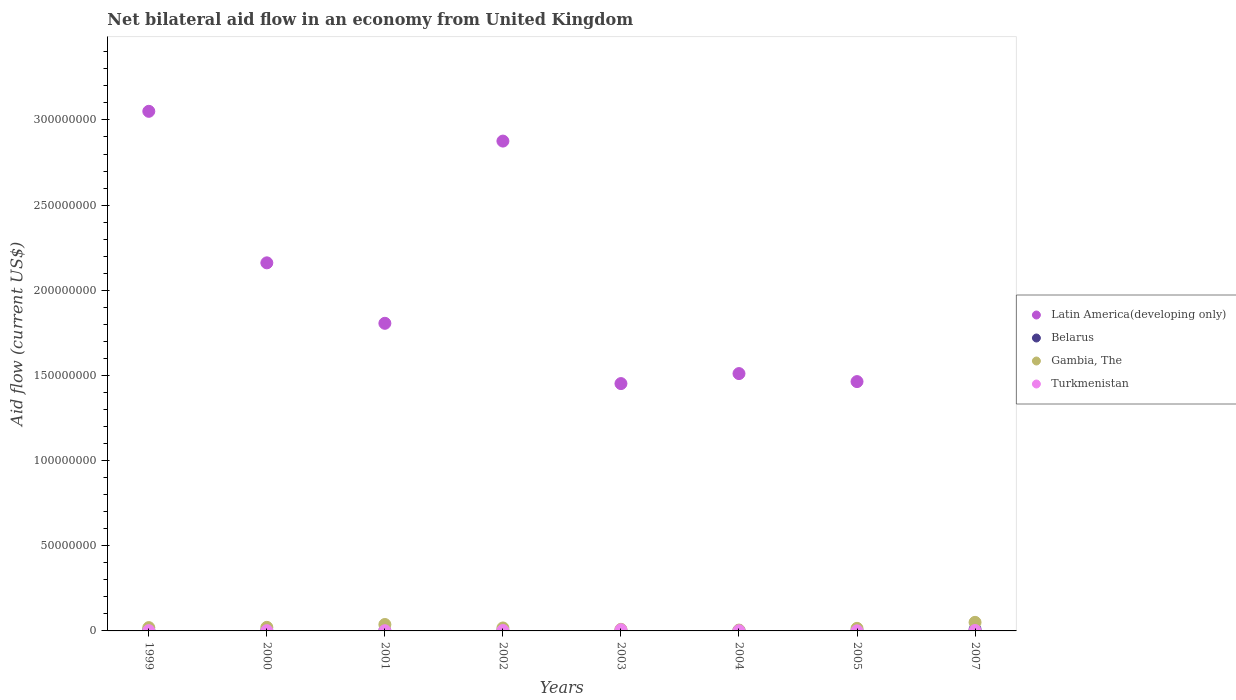What is the net bilateral aid flow in Latin America(developing only) in 2005?
Provide a short and direct response. 1.46e+08. Across all years, what is the maximum net bilateral aid flow in Gambia, The?
Keep it short and to the point. 5.03e+06. Across all years, what is the minimum net bilateral aid flow in Latin America(developing only)?
Keep it short and to the point. 0. What is the total net bilateral aid flow in Gambia, The in the graph?
Your answer should be compact. 1.75e+07. What is the difference between the net bilateral aid flow in Gambia, The in 2001 and that in 2005?
Provide a short and direct response. 2.26e+06. What is the difference between the net bilateral aid flow in Gambia, The in 2002 and the net bilateral aid flow in Latin America(developing only) in 2005?
Provide a succinct answer. -1.45e+08. What is the average net bilateral aid flow in Belarus per year?
Provide a succinct answer. 2.76e+05. In the year 2000, what is the difference between the net bilateral aid flow in Gambia, The and net bilateral aid flow in Turkmenistan?
Your response must be concise. 1.96e+06. In how many years, is the net bilateral aid flow in Gambia, The greater than 200000000 US$?
Make the answer very short. 0. Is the difference between the net bilateral aid flow in Gambia, The in 2001 and 2005 greater than the difference between the net bilateral aid flow in Turkmenistan in 2001 and 2005?
Your answer should be very brief. Yes. What is the difference between the highest and the second highest net bilateral aid flow in Latin America(developing only)?
Your answer should be compact. 1.75e+07. What is the difference between the highest and the lowest net bilateral aid flow in Turkmenistan?
Provide a succinct answer. 6.20e+05. In how many years, is the net bilateral aid flow in Turkmenistan greater than the average net bilateral aid flow in Turkmenistan taken over all years?
Offer a terse response. 3. Is the sum of the net bilateral aid flow in Belarus in 1999 and 2001 greater than the maximum net bilateral aid flow in Latin America(developing only) across all years?
Give a very brief answer. No. Is it the case that in every year, the sum of the net bilateral aid flow in Gambia, The and net bilateral aid flow in Turkmenistan  is greater than the net bilateral aid flow in Latin America(developing only)?
Your response must be concise. No. Is the net bilateral aid flow in Turkmenistan strictly greater than the net bilateral aid flow in Latin America(developing only) over the years?
Provide a short and direct response. No. How many dotlines are there?
Make the answer very short. 4. What is the difference between two consecutive major ticks on the Y-axis?
Ensure brevity in your answer.  5.00e+07. Does the graph contain any zero values?
Offer a very short reply. Yes. Does the graph contain grids?
Provide a short and direct response. No. Where does the legend appear in the graph?
Your answer should be very brief. Center right. How many legend labels are there?
Keep it short and to the point. 4. How are the legend labels stacked?
Your response must be concise. Vertical. What is the title of the graph?
Give a very brief answer. Net bilateral aid flow in an economy from United Kingdom. Does "Bhutan" appear as one of the legend labels in the graph?
Ensure brevity in your answer.  No. What is the label or title of the X-axis?
Keep it short and to the point. Years. What is the Aid flow (current US$) in Latin America(developing only) in 1999?
Make the answer very short. 3.05e+08. What is the Aid flow (current US$) in Belarus in 1999?
Make the answer very short. 5.80e+05. What is the Aid flow (current US$) of Gambia, The in 1999?
Offer a terse response. 1.94e+06. What is the Aid flow (current US$) of Latin America(developing only) in 2000?
Make the answer very short. 2.16e+08. What is the Aid flow (current US$) of Gambia, The in 2000?
Offer a terse response. 2.10e+06. What is the Aid flow (current US$) of Latin America(developing only) in 2001?
Give a very brief answer. 1.81e+08. What is the Aid flow (current US$) in Belarus in 2001?
Ensure brevity in your answer.  1.30e+05. What is the Aid flow (current US$) of Gambia, The in 2001?
Make the answer very short. 3.77e+06. What is the Aid flow (current US$) in Latin America(developing only) in 2002?
Offer a very short reply. 2.88e+08. What is the Aid flow (current US$) in Gambia, The in 2002?
Offer a very short reply. 1.73e+06. What is the Aid flow (current US$) of Turkmenistan in 2002?
Give a very brief answer. 2.40e+05. What is the Aid flow (current US$) in Latin America(developing only) in 2003?
Make the answer very short. 1.45e+08. What is the Aid flow (current US$) of Gambia, The in 2003?
Give a very brief answer. 9.30e+05. What is the Aid flow (current US$) in Turkmenistan in 2003?
Offer a very short reply. 6.70e+05. What is the Aid flow (current US$) in Latin America(developing only) in 2004?
Offer a very short reply. 1.51e+08. What is the Aid flow (current US$) of Belarus in 2004?
Provide a short and direct response. 2.00e+05. What is the Aid flow (current US$) of Turkmenistan in 2004?
Your answer should be compact. 1.10e+05. What is the Aid flow (current US$) of Latin America(developing only) in 2005?
Offer a very short reply. 1.46e+08. What is the Aid flow (current US$) in Belarus in 2005?
Provide a succinct answer. 1.10e+05. What is the Aid flow (current US$) of Gambia, The in 2005?
Ensure brevity in your answer.  1.51e+06. What is the Aid flow (current US$) of Latin America(developing only) in 2007?
Offer a terse response. 0. What is the Aid flow (current US$) in Belarus in 2007?
Your response must be concise. 8.20e+05. What is the Aid flow (current US$) of Gambia, The in 2007?
Your answer should be very brief. 5.03e+06. What is the Aid flow (current US$) in Turkmenistan in 2007?
Keep it short and to the point. 2.40e+05. Across all years, what is the maximum Aid flow (current US$) of Latin America(developing only)?
Your response must be concise. 3.05e+08. Across all years, what is the maximum Aid flow (current US$) in Belarus?
Provide a succinct answer. 8.20e+05. Across all years, what is the maximum Aid flow (current US$) of Gambia, The?
Keep it short and to the point. 5.03e+06. Across all years, what is the maximum Aid flow (current US$) in Turkmenistan?
Give a very brief answer. 6.70e+05. What is the total Aid flow (current US$) in Latin America(developing only) in the graph?
Keep it short and to the point. 1.43e+09. What is the total Aid flow (current US$) of Belarus in the graph?
Offer a terse response. 2.21e+06. What is the total Aid flow (current US$) of Gambia, The in the graph?
Ensure brevity in your answer.  1.75e+07. What is the total Aid flow (current US$) of Turkmenistan in the graph?
Make the answer very short. 1.73e+06. What is the difference between the Aid flow (current US$) of Latin America(developing only) in 1999 and that in 2000?
Keep it short and to the point. 8.90e+07. What is the difference between the Aid flow (current US$) of Belarus in 1999 and that in 2000?
Your answer should be compact. 3.70e+05. What is the difference between the Aid flow (current US$) in Gambia, The in 1999 and that in 2000?
Keep it short and to the point. -1.60e+05. What is the difference between the Aid flow (current US$) of Turkmenistan in 1999 and that in 2000?
Provide a short and direct response. 2.00e+04. What is the difference between the Aid flow (current US$) of Latin America(developing only) in 1999 and that in 2001?
Your answer should be very brief. 1.24e+08. What is the difference between the Aid flow (current US$) of Gambia, The in 1999 and that in 2001?
Your answer should be very brief. -1.83e+06. What is the difference between the Aid flow (current US$) of Latin America(developing only) in 1999 and that in 2002?
Your answer should be very brief. 1.75e+07. What is the difference between the Aid flow (current US$) of Belarus in 1999 and that in 2002?
Your answer should be compact. 4.90e+05. What is the difference between the Aid flow (current US$) of Gambia, The in 1999 and that in 2002?
Ensure brevity in your answer.  2.10e+05. What is the difference between the Aid flow (current US$) in Turkmenistan in 1999 and that in 2002?
Keep it short and to the point. -8.00e+04. What is the difference between the Aid flow (current US$) of Latin America(developing only) in 1999 and that in 2003?
Ensure brevity in your answer.  1.60e+08. What is the difference between the Aid flow (current US$) in Belarus in 1999 and that in 2003?
Ensure brevity in your answer.  5.10e+05. What is the difference between the Aid flow (current US$) of Gambia, The in 1999 and that in 2003?
Make the answer very short. 1.01e+06. What is the difference between the Aid flow (current US$) in Turkmenistan in 1999 and that in 2003?
Ensure brevity in your answer.  -5.10e+05. What is the difference between the Aid flow (current US$) in Latin America(developing only) in 1999 and that in 2004?
Your answer should be very brief. 1.54e+08. What is the difference between the Aid flow (current US$) of Belarus in 1999 and that in 2004?
Ensure brevity in your answer.  3.80e+05. What is the difference between the Aid flow (current US$) in Gambia, The in 1999 and that in 2004?
Give a very brief answer. 1.45e+06. What is the difference between the Aid flow (current US$) in Turkmenistan in 1999 and that in 2004?
Offer a very short reply. 5.00e+04. What is the difference between the Aid flow (current US$) of Latin America(developing only) in 1999 and that in 2005?
Your response must be concise. 1.59e+08. What is the difference between the Aid flow (current US$) of Belarus in 1999 and that in 2005?
Provide a short and direct response. 4.70e+05. What is the difference between the Aid flow (current US$) of Turkmenistan in 1999 and that in 2005?
Your answer should be compact. 1.10e+05. What is the difference between the Aid flow (current US$) of Belarus in 1999 and that in 2007?
Your response must be concise. -2.40e+05. What is the difference between the Aid flow (current US$) in Gambia, The in 1999 and that in 2007?
Keep it short and to the point. -3.09e+06. What is the difference between the Aid flow (current US$) of Latin America(developing only) in 2000 and that in 2001?
Make the answer very short. 3.55e+07. What is the difference between the Aid flow (current US$) of Gambia, The in 2000 and that in 2001?
Provide a succinct answer. -1.67e+06. What is the difference between the Aid flow (current US$) in Turkmenistan in 2000 and that in 2001?
Provide a succinct answer. 2.00e+04. What is the difference between the Aid flow (current US$) of Latin America(developing only) in 2000 and that in 2002?
Offer a very short reply. -7.15e+07. What is the difference between the Aid flow (current US$) in Belarus in 2000 and that in 2002?
Provide a succinct answer. 1.20e+05. What is the difference between the Aid flow (current US$) in Gambia, The in 2000 and that in 2002?
Your response must be concise. 3.70e+05. What is the difference between the Aid flow (current US$) in Latin America(developing only) in 2000 and that in 2003?
Ensure brevity in your answer.  7.09e+07. What is the difference between the Aid flow (current US$) of Gambia, The in 2000 and that in 2003?
Make the answer very short. 1.17e+06. What is the difference between the Aid flow (current US$) in Turkmenistan in 2000 and that in 2003?
Give a very brief answer. -5.30e+05. What is the difference between the Aid flow (current US$) of Latin America(developing only) in 2000 and that in 2004?
Provide a succinct answer. 6.50e+07. What is the difference between the Aid flow (current US$) of Gambia, The in 2000 and that in 2004?
Offer a very short reply. 1.61e+06. What is the difference between the Aid flow (current US$) of Turkmenistan in 2000 and that in 2004?
Provide a short and direct response. 3.00e+04. What is the difference between the Aid flow (current US$) in Latin America(developing only) in 2000 and that in 2005?
Give a very brief answer. 6.97e+07. What is the difference between the Aid flow (current US$) of Belarus in 2000 and that in 2005?
Give a very brief answer. 1.00e+05. What is the difference between the Aid flow (current US$) of Gambia, The in 2000 and that in 2005?
Keep it short and to the point. 5.90e+05. What is the difference between the Aid flow (current US$) of Turkmenistan in 2000 and that in 2005?
Offer a terse response. 9.00e+04. What is the difference between the Aid flow (current US$) in Belarus in 2000 and that in 2007?
Ensure brevity in your answer.  -6.10e+05. What is the difference between the Aid flow (current US$) in Gambia, The in 2000 and that in 2007?
Offer a very short reply. -2.93e+06. What is the difference between the Aid flow (current US$) in Turkmenistan in 2000 and that in 2007?
Your answer should be very brief. -1.00e+05. What is the difference between the Aid flow (current US$) of Latin America(developing only) in 2001 and that in 2002?
Offer a very short reply. -1.07e+08. What is the difference between the Aid flow (current US$) of Gambia, The in 2001 and that in 2002?
Keep it short and to the point. 2.04e+06. What is the difference between the Aid flow (current US$) in Latin America(developing only) in 2001 and that in 2003?
Provide a succinct answer. 3.54e+07. What is the difference between the Aid flow (current US$) in Belarus in 2001 and that in 2003?
Your response must be concise. 6.00e+04. What is the difference between the Aid flow (current US$) in Gambia, The in 2001 and that in 2003?
Provide a short and direct response. 2.84e+06. What is the difference between the Aid flow (current US$) of Turkmenistan in 2001 and that in 2003?
Provide a succinct answer. -5.50e+05. What is the difference between the Aid flow (current US$) of Latin America(developing only) in 2001 and that in 2004?
Offer a very short reply. 2.95e+07. What is the difference between the Aid flow (current US$) in Gambia, The in 2001 and that in 2004?
Make the answer very short. 3.28e+06. What is the difference between the Aid flow (current US$) in Turkmenistan in 2001 and that in 2004?
Offer a terse response. 10000. What is the difference between the Aid flow (current US$) in Latin America(developing only) in 2001 and that in 2005?
Your answer should be very brief. 3.42e+07. What is the difference between the Aid flow (current US$) of Gambia, The in 2001 and that in 2005?
Give a very brief answer. 2.26e+06. What is the difference between the Aid flow (current US$) in Turkmenistan in 2001 and that in 2005?
Your response must be concise. 7.00e+04. What is the difference between the Aid flow (current US$) in Belarus in 2001 and that in 2007?
Your answer should be very brief. -6.90e+05. What is the difference between the Aid flow (current US$) of Gambia, The in 2001 and that in 2007?
Your answer should be compact. -1.26e+06. What is the difference between the Aid flow (current US$) in Latin America(developing only) in 2002 and that in 2003?
Provide a short and direct response. 1.42e+08. What is the difference between the Aid flow (current US$) in Turkmenistan in 2002 and that in 2003?
Offer a very short reply. -4.30e+05. What is the difference between the Aid flow (current US$) in Latin America(developing only) in 2002 and that in 2004?
Your response must be concise. 1.36e+08. What is the difference between the Aid flow (current US$) of Gambia, The in 2002 and that in 2004?
Give a very brief answer. 1.24e+06. What is the difference between the Aid flow (current US$) in Latin America(developing only) in 2002 and that in 2005?
Provide a short and direct response. 1.41e+08. What is the difference between the Aid flow (current US$) of Belarus in 2002 and that in 2007?
Offer a very short reply. -7.30e+05. What is the difference between the Aid flow (current US$) of Gambia, The in 2002 and that in 2007?
Offer a terse response. -3.30e+06. What is the difference between the Aid flow (current US$) in Latin America(developing only) in 2003 and that in 2004?
Give a very brief answer. -5.87e+06. What is the difference between the Aid flow (current US$) of Turkmenistan in 2003 and that in 2004?
Provide a short and direct response. 5.60e+05. What is the difference between the Aid flow (current US$) of Latin America(developing only) in 2003 and that in 2005?
Your answer should be compact. -1.17e+06. What is the difference between the Aid flow (current US$) in Gambia, The in 2003 and that in 2005?
Keep it short and to the point. -5.80e+05. What is the difference between the Aid flow (current US$) of Turkmenistan in 2003 and that in 2005?
Offer a terse response. 6.20e+05. What is the difference between the Aid flow (current US$) of Belarus in 2003 and that in 2007?
Keep it short and to the point. -7.50e+05. What is the difference between the Aid flow (current US$) of Gambia, The in 2003 and that in 2007?
Make the answer very short. -4.10e+06. What is the difference between the Aid flow (current US$) in Latin America(developing only) in 2004 and that in 2005?
Offer a terse response. 4.70e+06. What is the difference between the Aid flow (current US$) in Gambia, The in 2004 and that in 2005?
Offer a very short reply. -1.02e+06. What is the difference between the Aid flow (current US$) of Turkmenistan in 2004 and that in 2005?
Keep it short and to the point. 6.00e+04. What is the difference between the Aid flow (current US$) in Belarus in 2004 and that in 2007?
Keep it short and to the point. -6.20e+05. What is the difference between the Aid flow (current US$) of Gambia, The in 2004 and that in 2007?
Make the answer very short. -4.54e+06. What is the difference between the Aid flow (current US$) of Turkmenistan in 2004 and that in 2007?
Ensure brevity in your answer.  -1.30e+05. What is the difference between the Aid flow (current US$) of Belarus in 2005 and that in 2007?
Provide a short and direct response. -7.10e+05. What is the difference between the Aid flow (current US$) of Gambia, The in 2005 and that in 2007?
Ensure brevity in your answer.  -3.52e+06. What is the difference between the Aid flow (current US$) of Turkmenistan in 2005 and that in 2007?
Provide a short and direct response. -1.90e+05. What is the difference between the Aid flow (current US$) of Latin America(developing only) in 1999 and the Aid flow (current US$) of Belarus in 2000?
Your answer should be compact. 3.05e+08. What is the difference between the Aid flow (current US$) in Latin America(developing only) in 1999 and the Aid flow (current US$) in Gambia, The in 2000?
Your answer should be compact. 3.03e+08. What is the difference between the Aid flow (current US$) in Latin America(developing only) in 1999 and the Aid flow (current US$) in Turkmenistan in 2000?
Offer a very short reply. 3.05e+08. What is the difference between the Aid flow (current US$) in Belarus in 1999 and the Aid flow (current US$) in Gambia, The in 2000?
Your answer should be very brief. -1.52e+06. What is the difference between the Aid flow (current US$) of Gambia, The in 1999 and the Aid flow (current US$) of Turkmenistan in 2000?
Your answer should be very brief. 1.80e+06. What is the difference between the Aid flow (current US$) in Latin America(developing only) in 1999 and the Aid flow (current US$) in Belarus in 2001?
Provide a succinct answer. 3.05e+08. What is the difference between the Aid flow (current US$) in Latin America(developing only) in 1999 and the Aid flow (current US$) in Gambia, The in 2001?
Provide a succinct answer. 3.01e+08. What is the difference between the Aid flow (current US$) in Latin America(developing only) in 1999 and the Aid flow (current US$) in Turkmenistan in 2001?
Provide a short and direct response. 3.05e+08. What is the difference between the Aid flow (current US$) of Belarus in 1999 and the Aid flow (current US$) of Gambia, The in 2001?
Provide a succinct answer. -3.19e+06. What is the difference between the Aid flow (current US$) of Gambia, The in 1999 and the Aid flow (current US$) of Turkmenistan in 2001?
Your answer should be compact. 1.82e+06. What is the difference between the Aid flow (current US$) in Latin America(developing only) in 1999 and the Aid flow (current US$) in Belarus in 2002?
Offer a terse response. 3.05e+08. What is the difference between the Aid flow (current US$) of Latin America(developing only) in 1999 and the Aid flow (current US$) of Gambia, The in 2002?
Keep it short and to the point. 3.03e+08. What is the difference between the Aid flow (current US$) in Latin America(developing only) in 1999 and the Aid flow (current US$) in Turkmenistan in 2002?
Offer a very short reply. 3.05e+08. What is the difference between the Aid flow (current US$) in Belarus in 1999 and the Aid flow (current US$) in Gambia, The in 2002?
Give a very brief answer. -1.15e+06. What is the difference between the Aid flow (current US$) in Belarus in 1999 and the Aid flow (current US$) in Turkmenistan in 2002?
Ensure brevity in your answer.  3.40e+05. What is the difference between the Aid flow (current US$) of Gambia, The in 1999 and the Aid flow (current US$) of Turkmenistan in 2002?
Provide a succinct answer. 1.70e+06. What is the difference between the Aid flow (current US$) in Latin America(developing only) in 1999 and the Aid flow (current US$) in Belarus in 2003?
Give a very brief answer. 3.05e+08. What is the difference between the Aid flow (current US$) in Latin America(developing only) in 1999 and the Aid flow (current US$) in Gambia, The in 2003?
Offer a terse response. 3.04e+08. What is the difference between the Aid flow (current US$) of Latin America(developing only) in 1999 and the Aid flow (current US$) of Turkmenistan in 2003?
Make the answer very short. 3.04e+08. What is the difference between the Aid flow (current US$) of Belarus in 1999 and the Aid flow (current US$) of Gambia, The in 2003?
Offer a very short reply. -3.50e+05. What is the difference between the Aid flow (current US$) in Gambia, The in 1999 and the Aid flow (current US$) in Turkmenistan in 2003?
Keep it short and to the point. 1.27e+06. What is the difference between the Aid flow (current US$) of Latin America(developing only) in 1999 and the Aid flow (current US$) of Belarus in 2004?
Provide a short and direct response. 3.05e+08. What is the difference between the Aid flow (current US$) of Latin America(developing only) in 1999 and the Aid flow (current US$) of Gambia, The in 2004?
Keep it short and to the point. 3.05e+08. What is the difference between the Aid flow (current US$) in Latin America(developing only) in 1999 and the Aid flow (current US$) in Turkmenistan in 2004?
Offer a terse response. 3.05e+08. What is the difference between the Aid flow (current US$) of Belarus in 1999 and the Aid flow (current US$) of Turkmenistan in 2004?
Offer a very short reply. 4.70e+05. What is the difference between the Aid flow (current US$) in Gambia, The in 1999 and the Aid flow (current US$) in Turkmenistan in 2004?
Offer a terse response. 1.83e+06. What is the difference between the Aid flow (current US$) in Latin America(developing only) in 1999 and the Aid flow (current US$) in Belarus in 2005?
Your answer should be very brief. 3.05e+08. What is the difference between the Aid flow (current US$) of Latin America(developing only) in 1999 and the Aid flow (current US$) of Gambia, The in 2005?
Provide a short and direct response. 3.04e+08. What is the difference between the Aid flow (current US$) in Latin America(developing only) in 1999 and the Aid flow (current US$) in Turkmenistan in 2005?
Your answer should be compact. 3.05e+08. What is the difference between the Aid flow (current US$) in Belarus in 1999 and the Aid flow (current US$) in Gambia, The in 2005?
Make the answer very short. -9.30e+05. What is the difference between the Aid flow (current US$) in Belarus in 1999 and the Aid flow (current US$) in Turkmenistan in 2005?
Offer a terse response. 5.30e+05. What is the difference between the Aid flow (current US$) in Gambia, The in 1999 and the Aid flow (current US$) in Turkmenistan in 2005?
Your answer should be very brief. 1.89e+06. What is the difference between the Aid flow (current US$) in Latin America(developing only) in 1999 and the Aid flow (current US$) in Belarus in 2007?
Ensure brevity in your answer.  3.04e+08. What is the difference between the Aid flow (current US$) in Latin America(developing only) in 1999 and the Aid flow (current US$) in Gambia, The in 2007?
Give a very brief answer. 3.00e+08. What is the difference between the Aid flow (current US$) in Latin America(developing only) in 1999 and the Aid flow (current US$) in Turkmenistan in 2007?
Give a very brief answer. 3.05e+08. What is the difference between the Aid flow (current US$) in Belarus in 1999 and the Aid flow (current US$) in Gambia, The in 2007?
Provide a short and direct response. -4.45e+06. What is the difference between the Aid flow (current US$) of Belarus in 1999 and the Aid flow (current US$) of Turkmenistan in 2007?
Keep it short and to the point. 3.40e+05. What is the difference between the Aid flow (current US$) of Gambia, The in 1999 and the Aid flow (current US$) of Turkmenistan in 2007?
Make the answer very short. 1.70e+06. What is the difference between the Aid flow (current US$) of Latin America(developing only) in 2000 and the Aid flow (current US$) of Belarus in 2001?
Keep it short and to the point. 2.16e+08. What is the difference between the Aid flow (current US$) of Latin America(developing only) in 2000 and the Aid flow (current US$) of Gambia, The in 2001?
Ensure brevity in your answer.  2.12e+08. What is the difference between the Aid flow (current US$) in Latin America(developing only) in 2000 and the Aid flow (current US$) in Turkmenistan in 2001?
Provide a succinct answer. 2.16e+08. What is the difference between the Aid flow (current US$) of Belarus in 2000 and the Aid flow (current US$) of Gambia, The in 2001?
Offer a very short reply. -3.56e+06. What is the difference between the Aid flow (current US$) in Belarus in 2000 and the Aid flow (current US$) in Turkmenistan in 2001?
Your answer should be compact. 9.00e+04. What is the difference between the Aid flow (current US$) in Gambia, The in 2000 and the Aid flow (current US$) in Turkmenistan in 2001?
Make the answer very short. 1.98e+06. What is the difference between the Aid flow (current US$) of Latin America(developing only) in 2000 and the Aid flow (current US$) of Belarus in 2002?
Offer a terse response. 2.16e+08. What is the difference between the Aid flow (current US$) of Latin America(developing only) in 2000 and the Aid flow (current US$) of Gambia, The in 2002?
Your response must be concise. 2.14e+08. What is the difference between the Aid flow (current US$) in Latin America(developing only) in 2000 and the Aid flow (current US$) in Turkmenistan in 2002?
Give a very brief answer. 2.16e+08. What is the difference between the Aid flow (current US$) of Belarus in 2000 and the Aid flow (current US$) of Gambia, The in 2002?
Provide a succinct answer. -1.52e+06. What is the difference between the Aid flow (current US$) in Belarus in 2000 and the Aid flow (current US$) in Turkmenistan in 2002?
Provide a short and direct response. -3.00e+04. What is the difference between the Aid flow (current US$) of Gambia, The in 2000 and the Aid flow (current US$) of Turkmenistan in 2002?
Your response must be concise. 1.86e+06. What is the difference between the Aid flow (current US$) in Latin America(developing only) in 2000 and the Aid flow (current US$) in Belarus in 2003?
Your response must be concise. 2.16e+08. What is the difference between the Aid flow (current US$) of Latin America(developing only) in 2000 and the Aid flow (current US$) of Gambia, The in 2003?
Keep it short and to the point. 2.15e+08. What is the difference between the Aid flow (current US$) in Latin America(developing only) in 2000 and the Aid flow (current US$) in Turkmenistan in 2003?
Your response must be concise. 2.15e+08. What is the difference between the Aid flow (current US$) in Belarus in 2000 and the Aid flow (current US$) in Gambia, The in 2003?
Your response must be concise. -7.20e+05. What is the difference between the Aid flow (current US$) in Belarus in 2000 and the Aid flow (current US$) in Turkmenistan in 2003?
Keep it short and to the point. -4.60e+05. What is the difference between the Aid flow (current US$) in Gambia, The in 2000 and the Aid flow (current US$) in Turkmenistan in 2003?
Your answer should be very brief. 1.43e+06. What is the difference between the Aid flow (current US$) in Latin America(developing only) in 2000 and the Aid flow (current US$) in Belarus in 2004?
Your response must be concise. 2.16e+08. What is the difference between the Aid flow (current US$) of Latin America(developing only) in 2000 and the Aid flow (current US$) of Gambia, The in 2004?
Your answer should be compact. 2.16e+08. What is the difference between the Aid flow (current US$) in Latin America(developing only) in 2000 and the Aid flow (current US$) in Turkmenistan in 2004?
Your answer should be very brief. 2.16e+08. What is the difference between the Aid flow (current US$) of Belarus in 2000 and the Aid flow (current US$) of Gambia, The in 2004?
Your response must be concise. -2.80e+05. What is the difference between the Aid flow (current US$) in Belarus in 2000 and the Aid flow (current US$) in Turkmenistan in 2004?
Provide a succinct answer. 1.00e+05. What is the difference between the Aid flow (current US$) of Gambia, The in 2000 and the Aid flow (current US$) of Turkmenistan in 2004?
Give a very brief answer. 1.99e+06. What is the difference between the Aid flow (current US$) in Latin America(developing only) in 2000 and the Aid flow (current US$) in Belarus in 2005?
Provide a short and direct response. 2.16e+08. What is the difference between the Aid flow (current US$) of Latin America(developing only) in 2000 and the Aid flow (current US$) of Gambia, The in 2005?
Provide a short and direct response. 2.15e+08. What is the difference between the Aid flow (current US$) of Latin America(developing only) in 2000 and the Aid flow (current US$) of Turkmenistan in 2005?
Offer a terse response. 2.16e+08. What is the difference between the Aid flow (current US$) in Belarus in 2000 and the Aid flow (current US$) in Gambia, The in 2005?
Ensure brevity in your answer.  -1.30e+06. What is the difference between the Aid flow (current US$) of Gambia, The in 2000 and the Aid flow (current US$) of Turkmenistan in 2005?
Offer a terse response. 2.05e+06. What is the difference between the Aid flow (current US$) of Latin America(developing only) in 2000 and the Aid flow (current US$) of Belarus in 2007?
Your answer should be compact. 2.15e+08. What is the difference between the Aid flow (current US$) in Latin America(developing only) in 2000 and the Aid flow (current US$) in Gambia, The in 2007?
Ensure brevity in your answer.  2.11e+08. What is the difference between the Aid flow (current US$) of Latin America(developing only) in 2000 and the Aid flow (current US$) of Turkmenistan in 2007?
Ensure brevity in your answer.  2.16e+08. What is the difference between the Aid flow (current US$) of Belarus in 2000 and the Aid flow (current US$) of Gambia, The in 2007?
Your answer should be very brief. -4.82e+06. What is the difference between the Aid flow (current US$) in Belarus in 2000 and the Aid flow (current US$) in Turkmenistan in 2007?
Offer a terse response. -3.00e+04. What is the difference between the Aid flow (current US$) in Gambia, The in 2000 and the Aid flow (current US$) in Turkmenistan in 2007?
Provide a succinct answer. 1.86e+06. What is the difference between the Aid flow (current US$) in Latin America(developing only) in 2001 and the Aid flow (current US$) in Belarus in 2002?
Your answer should be compact. 1.81e+08. What is the difference between the Aid flow (current US$) in Latin America(developing only) in 2001 and the Aid flow (current US$) in Gambia, The in 2002?
Provide a short and direct response. 1.79e+08. What is the difference between the Aid flow (current US$) in Latin America(developing only) in 2001 and the Aid flow (current US$) in Turkmenistan in 2002?
Give a very brief answer. 1.80e+08. What is the difference between the Aid flow (current US$) in Belarus in 2001 and the Aid flow (current US$) in Gambia, The in 2002?
Your response must be concise. -1.60e+06. What is the difference between the Aid flow (current US$) of Belarus in 2001 and the Aid flow (current US$) of Turkmenistan in 2002?
Your answer should be compact. -1.10e+05. What is the difference between the Aid flow (current US$) of Gambia, The in 2001 and the Aid flow (current US$) of Turkmenistan in 2002?
Offer a very short reply. 3.53e+06. What is the difference between the Aid flow (current US$) of Latin America(developing only) in 2001 and the Aid flow (current US$) of Belarus in 2003?
Offer a terse response. 1.81e+08. What is the difference between the Aid flow (current US$) of Latin America(developing only) in 2001 and the Aid flow (current US$) of Gambia, The in 2003?
Provide a succinct answer. 1.80e+08. What is the difference between the Aid flow (current US$) of Latin America(developing only) in 2001 and the Aid flow (current US$) of Turkmenistan in 2003?
Provide a short and direct response. 1.80e+08. What is the difference between the Aid flow (current US$) in Belarus in 2001 and the Aid flow (current US$) in Gambia, The in 2003?
Make the answer very short. -8.00e+05. What is the difference between the Aid flow (current US$) of Belarus in 2001 and the Aid flow (current US$) of Turkmenistan in 2003?
Your response must be concise. -5.40e+05. What is the difference between the Aid flow (current US$) of Gambia, The in 2001 and the Aid flow (current US$) of Turkmenistan in 2003?
Provide a succinct answer. 3.10e+06. What is the difference between the Aid flow (current US$) of Latin America(developing only) in 2001 and the Aid flow (current US$) of Belarus in 2004?
Provide a succinct answer. 1.80e+08. What is the difference between the Aid flow (current US$) of Latin America(developing only) in 2001 and the Aid flow (current US$) of Gambia, The in 2004?
Your response must be concise. 1.80e+08. What is the difference between the Aid flow (current US$) of Latin America(developing only) in 2001 and the Aid flow (current US$) of Turkmenistan in 2004?
Your answer should be very brief. 1.80e+08. What is the difference between the Aid flow (current US$) in Belarus in 2001 and the Aid flow (current US$) in Gambia, The in 2004?
Ensure brevity in your answer.  -3.60e+05. What is the difference between the Aid flow (current US$) in Belarus in 2001 and the Aid flow (current US$) in Turkmenistan in 2004?
Provide a succinct answer. 2.00e+04. What is the difference between the Aid flow (current US$) of Gambia, The in 2001 and the Aid flow (current US$) of Turkmenistan in 2004?
Provide a succinct answer. 3.66e+06. What is the difference between the Aid flow (current US$) in Latin America(developing only) in 2001 and the Aid flow (current US$) in Belarus in 2005?
Provide a short and direct response. 1.80e+08. What is the difference between the Aid flow (current US$) in Latin America(developing only) in 2001 and the Aid flow (current US$) in Gambia, The in 2005?
Your response must be concise. 1.79e+08. What is the difference between the Aid flow (current US$) of Latin America(developing only) in 2001 and the Aid flow (current US$) of Turkmenistan in 2005?
Offer a terse response. 1.81e+08. What is the difference between the Aid flow (current US$) in Belarus in 2001 and the Aid flow (current US$) in Gambia, The in 2005?
Provide a short and direct response. -1.38e+06. What is the difference between the Aid flow (current US$) of Belarus in 2001 and the Aid flow (current US$) of Turkmenistan in 2005?
Give a very brief answer. 8.00e+04. What is the difference between the Aid flow (current US$) in Gambia, The in 2001 and the Aid flow (current US$) in Turkmenistan in 2005?
Ensure brevity in your answer.  3.72e+06. What is the difference between the Aid flow (current US$) in Latin America(developing only) in 2001 and the Aid flow (current US$) in Belarus in 2007?
Offer a very short reply. 1.80e+08. What is the difference between the Aid flow (current US$) in Latin America(developing only) in 2001 and the Aid flow (current US$) in Gambia, The in 2007?
Offer a terse response. 1.76e+08. What is the difference between the Aid flow (current US$) in Latin America(developing only) in 2001 and the Aid flow (current US$) in Turkmenistan in 2007?
Ensure brevity in your answer.  1.80e+08. What is the difference between the Aid flow (current US$) of Belarus in 2001 and the Aid flow (current US$) of Gambia, The in 2007?
Your answer should be compact. -4.90e+06. What is the difference between the Aid flow (current US$) of Gambia, The in 2001 and the Aid flow (current US$) of Turkmenistan in 2007?
Your answer should be very brief. 3.53e+06. What is the difference between the Aid flow (current US$) in Latin America(developing only) in 2002 and the Aid flow (current US$) in Belarus in 2003?
Give a very brief answer. 2.88e+08. What is the difference between the Aid flow (current US$) of Latin America(developing only) in 2002 and the Aid flow (current US$) of Gambia, The in 2003?
Ensure brevity in your answer.  2.87e+08. What is the difference between the Aid flow (current US$) of Latin America(developing only) in 2002 and the Aid flow (current US$) of Turkmenistan in 2003?
Make the answer very short. 2.87e+08. What is the difference between the Aid flow (current US$) of Belarus in 2002 and the Aid flow (current US$) of Gambia, The in 2003?
Keep it short and to the point. -8.40e+05. What is the difference between the Aid flow (current US$) of Belarus in 2002 and the Aid flow (current US$) of Turkmenistan in 2003?
Make the answer very short. -5.80e+05. What is the difference between the Aid flow (current US$) of Gambia, The in 2002 and the Aid flow (current US$) of Turkmenistan in 2003?
Provide a succinct answer. 1.06e+06. What is the difference between the Aid flow (current US$) in Latin America(developing only) in 2002 and the Aid flow (current US$) in Belarus in 2004?
Your response must be concise. 2.87e+08. What is the difference between the Aid flow (current US$) of Latin America(developing only) in 2002 and the Aid flow (current US$) of Gambia, The in 2004?
Offer a very short reply. 2.87e+08. What is the difference between the Aid flow (current US$) of Latin America(developing only) in 2002 and the Aid flow (current US$) of Turkmenistan in 2004?
Your answer should be compact. 2.87e+08. What is the difference between the Aid flow (current US$) of Belarus in 2002 and the Aid flow (current US$) of Gambia, The in 2004?
Your response must be concise. -4.00e+05. What is the difference between the Aid flow (current US$) in Belarus in 2002 and the Aid flow (current US$) in Turkmenistan in 2004?
Keep it short and to the point. -2.00e+04. What is the difference between the Aid flow (current US$) in Gambia, The in 2002 and the Aid flow (current US$) in Turkmenistan in 2004?
Make the answer very short. 1.62e+06. What is the difference between the Aid flow (current US$) of Latin America(developing only) in 2002 and the Aid flow (current US$) of Belarus in 2005?
Provide a succinct answer. 2.87e+08. What is the difference between the Aid flow (current US$) of Latin America(developing only) in 2002 and the Aid flow (current US$) of Gambia, The in 2005?
Your answer should be very brief. 2.86e+08. What is the difference between the Aid flow (current US$) of Latin America(developing only) in 2002 and the Aid flow (current US$) of Turkmenistan in 2005?
Keep it short and to the point. 2.88e+08. What is the difference between the Aid flow (current US$) of Belarus in 2002 and the Aid flow (current US$) of Gambia, The in 2005?
Give a very brief answer. -1.42e+06. What is the difference between the Aid flow (current US$) of Gambia, The in 2002 and the Aid flow (current US$) of Turkmenistan in 2005?
Keep it short and to the point. 1.68e+06. What is the difference between the Aid flow (current US$) of Latin America(developing only) in 2002 and the Aid flow (current US$) of Belarus in 2007?
Provide a succinct answer. 2.87e+08. What is the difference between the Aid flow (current US$) of Latin America(developing only) in 2002 and the Aid flow (current US$) of Gambia, The in 2007?
Give a very brief answer. 2.83e+08. What is the difference between the Aid flow (current US$) of Latin America(developing only) in 2002 and the Aid flow (current US$) of Turkmenistan in 2007?
Give a very brief answer. 2.87e+08. What is the difference between the Aid flow (current US$) in Belarus in 2002 and the Aid flow (current US$) in Gambia, The in 2007?
Make the answer very short. -4.94e+06. What is the difference between the Aid flow (current US$) in Belarus in 2002 and the Aid flow (current US$) in Turkmenistan in 2007?
Offer a very short reply. -1.50e+05. What is the difference between the Aid flow (current US$) of Gambia, The in 2002 and the Aid flow (current US$) of Turkmenistan in 2007?
Provide a short and direct response. 1.49e+06. What is the difference between the Aid flow (current US$) in Latin America(developing only) in 2003 and the Aid flow (current US$) in Belarus in 2004?
Provide a succinct answer. 1.45e+08. What is the difference between the Aid flow (current US$) of Latin America(developing only) in 2003 and the Aid flow (current US$) of Gambia, The in 2004?
Keep it short and to the point. 1.45e+08. What is the difference between the Aid flow (current US$) of Latin America(developing only) in 2003 and the Aid flow (current US$) of Turkmenistan in 2004?
Offer a terse response. 1.45e+08. What is the difference between the Aid flow (current US$) of Belarus in 2003 and the Aid flow (current US$) of Gambia, The in 2004?
Your response must be concise. -4.20e+05. What is the difference between the Aid flow (current US$) in Belarus in 2003 and the Aid flow (current US$) in Turkmenistan in 2004?
Your answer should be compact. -4.00e+04. What is the difference between the Aid flow (current US$) of Gambia, The in 2003 and the Aid flow (current US$) of Turkmenistan in 2004?
Provide a succinct answer. 8.20e+05. What is the difference between the Aid flow (current US$) of Latin America(developing only) in 2003 and the Aid flow (current US$) of Belarus in 2005?
Provide a short and direct response. 1.45e+08. What is the difference between the Aid flow (current US$) of Latin America(developing only) in 2003 and the Aid flow (current US$) of Gambia, The in 2005?
Your answer should be compact. 1.44e+08. What is the difference between the Aid flow (current US$) of Latin America(developing only) in 2003 and the Aid flow (current US$) of Turkmenistan in 2005?
Your answer should be compact. 1.45e+08. What is the difference between the Aid flow (current US$) of Belarus in 2003 and the Aid flow (current US$) of Gambia, The in 2005?
Offer a very short reply. -1.44e+06. What is the difference between the Aid flow (current US$) of Belarus in 2003 and the Aid flow (current US$) of Turkmenistan in 2005?
Your answer should be compact. 2.00e+04. What is the difference between the Aid flow (current US$) of Gambia, The in 2003 and the Aid flow (current US$) of Turkmenistan in 2005?
Provide a succinct answer. 8.80e+05. What is the difference between the Aid flow (current US$) of Latin America(developing only) in 2003 and the Aid flow (current US$) of Belarus in 2007?
Offer a very short reply. 1.44e+08. What is the difference between the Aid flow (current US$) in Latin America(developing only) in 2003 and the Aid flow (current US$) in Gambia, The in 2007?
Your response must be concise. 1.40e+08. What is the difference between the Aid flow (current US$) of Latin America(developing only) in 2003 and the Aid flow (current US$) of Turkmenistan in 2007?
Give a very brief answer. 1.45e+08. What is the difference between the Aid flow (current US$) of Belarus in 2003 and the Aid flow (current US$) of Gambia, The in 2007?
Your answer should be very brief. -4.96e+06. What is the difference between the Aid flow (current US$) in Belarus in 2003 and the Aid flow (current US$) in Turkmenistan in 2007?
Give a very brief answer. -1.70e+05. What is the difference between the Aid flow (current US$) of Gambia, The in 2003 and the Aid flow (current US$) of Turkmenistan in 2007?
Offer a terse response. 6.90e+05. What is the difference between the Aid flow (current US$) of Latin America(developing only) in 2004 and the Aid flow (current US$) of Belarus in 2005?
Offer a very short reply. 1.51e+08. What is the difference between the Aid flow (current US$) in Latin America(developing only) in 2004 and the Aid flow (current US$) in Gambia, The in 2005?
Provide a succinct answer. 1.50e+08. What is the difference between the Aid flow (current US$) in Latin America(developing only) in 2004 and the Aid flow (current US$) in Turkmenistan in 2005?
Keep it short and to the point. 1.51e+08. What is the difference between the Aid flow (current US$) of Belarus in 2004 and the Aid flow (current US$) of Gambia, The in 2005?
Keep it short and to the point. -1.31e+06. What is the difference between the Aid flow (current US$) of Latin America(developing only) in 2004 and the Aid flow (current US$) of Belarus in 2007?
Provide a short and direct response. 1.50e+08. What is the difference between the Aid flow (current US$) of Latin America(developing only) in 2004 and the Aid flow (current US$) of Gambia, The in 2007?
Your response must be concise. 1.46e+08. What is the difference between the Aid flow (current US$) of Latin America(developing only) in 2004 and the Aid flow (current US$) of Turkmenistan in 2007?
Provide a succinct answer. 1.51e+08. What is the difference between the Aid flow (current US$) of Belarus in 2004 and the Aid flow (current US$) of Gambia, The in 2007?
Provide a succinct answer. -4.83e+06. What is the difference between the Aid flow (current US$) of Gambia, The in 2004 and the Aid flow (current US$) of Turkmenistan in 2007?
Ensure brevity in your answer.  2.50e+05. What is the difference between the Aid flow (current US$) in Latin America(developing only) in 2005 and the Aid flow (current US$) in Belarus in 2007?
Offer a very short reply. 1.46e+08. What is the difference between the Aid flow (current US$) in Latin America(developing only) in 2005 and the Aid flow (current US$) in Gambia, The in 2007?
Give a very brief answer. 1.41e+08. What is the difference between the Aid flow (current US$) in Latin America(developing only) in 2005 and the Aid flow (current US$) in Turkmenistan in 2007?
Keep it short and to the point. 1.46e+08. What is the difference between the Aid flow (current US$) of Belarus in 2005 and the Aid flow (current US$) of Gambia, The in 2007?
Give a very brief answer. -4.92e+06. What is the difference between the Aid flow (current US$) in Gambia, The in 2005 and the Aid flow (current US$) in Turkmenistan in 2007?
Your answer should be very brief. 1.27e+06. What is the average Aid flow (current US$) of Latin America(developing only) per year?
Your response must be concise. 1.79e+08. What is the average Aid flow (current US$) in Belarus per year?
Keep it short and to the point. 2.76e+05. What is the average Aid flow (current US$) of Gambia, The per year?
Provide a short and direct response. 2.19e+06. What is the average Aid flow (current US$) of Turkmenistan per year?
Your response must be concise. 2.16e+05. In the year 1999, what is the difference between the Aid flow (current US$) in Latin America(developing only) and Aid flow (current US$) in Belarus?
Give a very brief answer. 3.04e+08. In the year 1999, what is the difference between the Aid flow (current US$) of Latin America(developing only) and Aid flow (current US$) of Gambia, The?
Keep it short and to the point. 3.03e+08. In the year 1999, what is the difference between the Aid flow (current US$) in Latin America(developing only) and Aid flow (current US$) in Turkmenistan?
Make the answer very short. 3.05e+08. In the year 1999, what is the difference between the Aid flow (current US$) of Belarus and Aid flow (current US$) of Gambia, The?
Your answer should be compact. -1.36e+06. In the year 1999, what is the difference between the Aid flow (current US$) of Belarus and Aid flow (current US$) of Turkmenistan?
Make the answer very short. 4.20e+05. In the year 1999, what is the difference between the Aid flow (current US$) of Gambia, The and Aid flow (current US$) of Turkmenistan?
Provide a short and direct response. 1.78e+06. In the year 2000, what is the difference between the Aid flow (current US$) of Latin America(developing only) and Aid flow (current US$) of Belarus?
Offer a terse response. 2.16e+08. In the year 2000, what is the difference between the Aid flow (current US$) in Latin America(developing only) and Aid flow (current US$) in Gambia, The?
Your answer should be very brief. 2.14e+08. In the year 2000, what is the difference between the Aid flow (current US$) in Latin America(developing only) and Aid flow (current US$) in Turkmenistan?
Make the answer very short. 2.16e+08. In the year 2000, what is the difference between the Aid flow (current US$) in Belarus and Aid flow (current US$) in Gambia, The?
Offer a very short reply. -1.89e+06. In the year 2000, what is the difference between the Aid flow (current US$) in Gambia, The and Aid flow (current US$) in Turkmenistan?
Provide a succinct answer. 1.96e+06. In the year 2001, what is the difference between the Aid flow (current US$) in Latin America(developing only) and Aid flow (current US$) in Belarus?
Provide a succinct answer. 1.80e+08. In the year 2001, what is the difference between the Aid flow (current US$) in Latin America(developing only) and Aid flow (current US$) in Gambia, The?
Provide a succinct answer. 1.77e+08. In the year 2001, what is the difference between the Aid flow (current US$) of Latin America(developing only) and Aid flow (current US$) of Turkmenistan?
Your response must be concise. 1.80e+08. In the year 2001, what is the difference between the Aid flow (current US$) in Belarus and Aid flow (current US$) in Gambia, The?
Your response must be concise. -3.64e+06. In the year 2001, what is the difference between the Aid flow (current US$) in Gambia, The and Aid flow (current US$) in Turkmenistan?
Provide a short and direct response. 3.65e+06. In the year 2002, what is the difference between the Aid flow (current US$) of Latin America(developing only) and Aid flow (current US$) of Belarus?
Provide a succinct answer. 2.87e+08. In the year 2002, what is the difference between the Aid flow (current US$) in Latin America(developing only) and Aid flow (current US$) in Gambia, The?
Provide a succinct answer. 2.86e+08. In the year 2002, what is the difference between the Aid flow (current US$) of Latin America(developing only) and Aid flow (current US$) of Turkmenistan?
Offer a very short reply. 2.87e+08. In the year 2002, what is the difference between the Aid flow (current US$) of Belarus and Aid flow (current US$) of Gambia, The?
Make the answer very short. -1.64e+06. In the year 2002, what is the difference between the Aid flow (current US$) in Gambia, The and Aid flow (current US$) in Turkmenistan?
Ensure brevity in your answer.  1.49e+06. In the year 2003, what is the difference between the Aid flow (current US$) in Latin America(developing only) and Aid flow (current US$) in Belarus?
Give a very brief answer. 1.45e+08. In the year 2003, what is the difference between the Aid flow (current US$) of Latin America(developing only) and Aid flow (current US$) of Gambia, The?
Provide a short and direct response. 1.44e+08. In the year 2003, what is the difference between the Aid flow (current US$) of Latin America(developing only) and Aid flow (current US$) of Turkmenistan?
Your response must be concise. 1.45e+08. In the year 2003, what is the difference between the Aid flow (current US$) of Belarus and Aid flow (current US$) of Gambia, The?
Keep it short and to the point. -8.60e+05. In the year 2003, what is the difference between the Aid flow (current US$) of Belarus and Aid flow (current US$) of Turkmenistan?
Offer a very short reply. -6.00e+05. In the year 2004, what is the difference between the Aid flow (current US$) in Latin America(developing only) and Aid flow (current US$) in Belarus?
Give a very brief answer. 1.51e+08. In the year 2004, what is the difference between the Aid flow (current US$) of Latin America(developing only) and Aid flow (current US$) of Gambia, The?
Offer a terse response. 1.51e+08. In the year 2004, what is the difference between the Aid flow (current US$) in Latin America(developing only) and Aid flow (current US$) in Turkmenistan?
Provide a short and direct response. 1.51e+08. In the year 2004, what is the difference between the Aid flow (current US$) of Gambia, The and Aid flow (current US$) of Turkmenistan?
Your answer should be compact. 3.80e+05. In the year 2005, what is the difference between the Aid flow (current US$) of Latin America(developing only) and Aid flow (current US$) of Belarus?
Your answer should be compact. 1.46e+08. In the year 2005, what is the difference between the Aid flow (current US$) of Latin America(developing only) and Aid flow (current US$) of Gambia, The?
Your answer should be very brief. 1.45e+08. In the year 2005, what is the difference between the Aid flow (current US$) in Latin America(developing only) and Aid flow (current US$) in Turkmenistan?
Your answer should be compact. 1.46e+08. In the year 2005, what is the difference between the Aid flow (current US$) of Belarus and Aid flow (current US$) of Gambia, The?
Give a very brief answer. -1.40e+06. In the year 2005, what is the difference between the Aid flow (current US$) in Belarus and Aid flow (current US$) in Turkmenistan?
Provide a succinct answer. 6.00e+04. In the year 2005, what is the difference between the Aid flow (current US$) of Gambia, The and Aid flow (current US$) of Turkmenistan?
Provide a short and direct response. 1.46e+06. In the year 2007, what is the difference between the Aid flow (current US$) in Belarus and Aid flow (current US$) in Gambia, The?
Your response must be concise. -4.21e+06. In the year 2007, what is the difference between the Aid flow (current US$) in Belarus and Aid flow (current US$) in Turkmenistan?
Ensure brevity in your answer.  5.80e+05. In the year 2007, what is the difference between the Aid flow (current US$) of Gambia, The and Aid flow (current US$) of Turkmenistan?
Your answer should be very brief. 4.79e+06. What is the ratio of the Aid flow (current US$) in Latin America(developing only) in 1999 to that in 2000?
Provide a succinct answer. 1.41. What is the ratio of the Aid flow (current US$) in Belarus in 1999 to that in 2000?
Offer a very short reply. 2.76. What is the ratio of the Aid flow (current US$) in Gambia, The in 1999 to that in 2000?
Offer a terse response. 0.92. What is the ratio of the Aid flow (current US$) of Turkmenistan in 1999 to that in 2000?
Offer a very short reply. 1.14. What is the ratio of the Aid flow (current US$) of Latin America(developing only) in 1999 to that in 2001?
Make the answer very short. 1.69. What is the ratio of the Aid flow (current US$) in Belarus in 1999 to that in 2001?
Offer a terse response. 4.46. What is the ratio of the Aid flow (current US$) in Gambia, The in 1999 to that in 2001?
Provide a short and direct response. 0.51. What is the ratio of the Aid flow (current US$) of Turkmenistan in 1999 to that in 2001?
Your answer should be compact. 1.33. What is the ratio of the Aid flow (current US$) of Latin America(developing only) in 1999 to that in 2002?
Provide a short and direct response. 1.06. What is the ratio of the Aid flow (current US$) in Belarus in 1999 to that in 2002?
Provide a succinct answer. 6.44. What is the ratio of the Aid flow (current US$) in Gambia, The in 1999 to that in 2002?
Offer a very short reply. 1.12. What is the ratio of the Aid flow (current US$) in Turkmenistan in 1999 to that in 2002?
Your answer should be very brief. 0.67. What is the ratio of the Aid flow (current US$) of Latin America(developing only) in 1999 to that in 2003?
Make the answer very short. 2.1. What is the ratio of the Aid flow (current US$) in Belarus in 1999 to that in 2003?
Your answer should be very brief. 8.29. What is the ratio of the Aid flow (current US$) in Gambia, The in 1999 to that in 2003?
Keep it short and to the point. 2.09. What is the ratio of the Aid flow (current US$) in Turkmenistan in 1999 to that in 2003?
Your answer should be compact. 0.24. What is the ratio of the Aid flow (current US$) of Latin America(developing only) in 1999 to that in 2004?
Keep it short and to the point. 2.02. What is the ratio of the Aid flow (current US$) of Belarus in 1999 to that in 2004?
Offer a very short reply. 2.9. What is the ratio of the Aid flow (current US$) in Gambia, The in 1999 to that in 2004?
Give a very brief answer. 3.96. What is the ratio of the Aid flow (current US$) of Turkmenistan in 1999 to that in 2004?
Make the answer very short. 1.45. What is the ratio of the Aid flow (current US$) of Latin America(developing only) in 1999 to that in 2005?
Make the answer very short. 2.08. What is the ratio of the Aid flow (current US$) in Belarus in 1999 to that in 2005?
Your response must be concise. 5.27. What is the ratio of the Aid flow (current US$) of Gambia, The in 1999 to that in 2005?
Offer a terse response. 1.28. What is the ratio of the Aid flow (current US$) of Turkmenistan in 1999 to that in 2005?
Offer a terse response. 3.2. What is the ratio of the Aid flow (current US$) of Belarus in 1999 to that in 2007?
Your answer should be very brief. 0.71. What is the ratio of the Aid flow (current US$) of Gambia, The in 1999 to that in 2007?
Your response must be concise. 0.39. What is the ratio of the Aid flow (current US$) of Turkmenistan in 1999 to that in 2007?
Offer a very short reply. 0.67. What is the ratio of the Aid flow (current US$) in Latin America(developing only) in 2000 to that in 2001?
Offer a terse response. 1.2. What is the ratio of the Aid flow (current US$) in Belarus in 2000 to that in 2001?
Make the answer very short. 1.62. What is the ratio of the Aid flow (current US$) of Gambia, The in 2000 to that in 2001?
Give a very brief answer. 0.56. What is the ratio of the Aid flow (current US$) in Latin America(developing only) in 2000 to that in 2002?
Give a very brief answer. 0.75. What is the ratio of the Aid flow (current US$) in Belarus in 2000 to that in 2002?
Keep it short and to the point. 2.33. What is the ratio of the Aid flow (current US$) in Gambia, The in 2000 to that in 2002?
Provide a succinct answer. 1.21. What is the ratio of the Aid flow (current US$) in Turkmenistan in 2000 to that in 2002?
Give a very brief answer. 0.58. What is the ratio of the Aid flow (current US$) of Latin America(developing only) in 2000 to that in 2003?
Your answer should be very brief. 1.49. What is the ratio of the Aid flow (current US$) of Gambia, The in 2000 to that in 2003?
Your answer should be compact. 2.26. What is the ratio of the Aid flow (current US$) of Turkmenistan in 2000 to that in 2003?
Provide a short and direct response. 0.21. What is the ratio of the Aid flow (current US$) of Latin America(developing only) in 2000 to that in 2004?
Offer a very short reply. 1.43. What is the ratio of the Aid flow (current US$) in Belarus in 2000 to that in 2004?
Offer a very short reply. 1.05. What is the ratio of the Aid flow (current US$) in Gambia, The in 2000 to that in 2004?
Offer a terse response. 4.29. What is the ratio of the Aid flow (current US$) in Turkmenistan in 2000 to that in 2004?
Make the answer very short. 1.27. What is the ratio of the Aid flow (current US$) of Latin America(developing only) in 2000 to that in 2005?
Provide a short and direct response. 1.48. What is the ratio of the Aid flow (current US$) in Belarus in 2000 to that in 2005?
Provide a short and direct response. 1.91. What is the ratio of the Aid flow (current US$) in Gambia, The in 2000 to that in 2005?
Provide a succinct answer. 1.39. What is the ratio of the Aid flow (current US$) of Belarus in 2000 to that in 2007?
Your response must be concise. 0.26. What is the ratio of the Aid flow (current US$) in Gambia, The in 2000 to that in 2007?
Offer a terse response. 0.42. What is the ratio of the Aid flow (current US$) in Turkmenistan in 2000 to that in 2007?
Keep it short and to the point. 0.58. What is the ratio of the Aid flow (current US$) of Latin America(developing only) in 2001 to that in 2002?
Provide a succinct answer. 0.63. What is the ratio of the Aid flow (current US$) of Belarus in 2001 to that in 2002?
Make the answer very short. 1.44. What is the ratio of the Aid flow (current US$) in Gambia, The in 2001 to that in 2002?
Offer a very short reply. 2.18. What is the ratio of the Aid flow (current US$) in Turkmenistan in 2001 to that in 2002?
Ensure brevity in your answer.  0.5. What is the ratio of the Aid flow (current US$) of Latin America(developing only) in 2001 to that in 2003?
Your answer should be very brief. 1.24. What is the ratio of the Aid flow (current US$) in Belarus in 2001 to that in 2003?
Keep it short and to the point. 1.86. What is the ratio of the Aid flow (current US$) in Gambia, The in 2001 to that in 2003?
Offer a terse response. 4.05. What is the ratio of the Aid flow (current US$) in Turkmenistan in 2001 to that in 2003?
Make the answer very short. 0.18. What is the ratio of the Aid flow (current US$) in Latin America(developing only) in 2001 to that in 2004?
Your response must be concise. 1.2. What is the ratio of the Aid flow (current US$) in Belarus in 2001 to that in 2004?
Offer a terse response. 0.65. What is the ratio of the Aid flow (current US$) in Gambia, The in 2001 to that in 2004?
Give a very brief answer. 7.69. What is the ratio of the Aid flow (current US$) of Turkmenistan in 2001 to that in 2004?
Your answer should be very brief. 1.09. What is the ratio of the Aid flow (current US$) in Latin America(developing only) in 2001 to that in 2005?
Offer a very short reply. 1.23. What is the ratio of the Aid flow (current US$) in Belarus in 2001 to that in 2005?
Give a very brief answer. 1.18. What is the ratio of the Aid flow (current US$) of Gambia, The in 2001 to that in 2005?
Offer a terse response. 2.5. What is the ratio of the Aid flow (current US$) in Turkmenistan in 2001 to that in 2005?
Offer a terse response. 2.4. What is the ratio of the Aid flow (current US$) of Belarus in 2001 to that in 2007?
Keep it short and to the point. 0.16. What is the ratio of the Aid flow (current US$) in Gambia, The in 2001 to that in 2007?
Provide a succinct answer. 0.75. What is the ratio of the Aid flow (current US$) in Turkmenistan in 2001 to that in 2007?
Your answer should be very brief. 0.5. What is the ratio of the Aid flow (current US$) of Latin America(developing only) in 2002 to that in 2003?
Your response must be concise. 1.98. What is the ratio of the Aid flow (current US$) in Gambia, The in 2002 to that in 2003?
Make the answer very short. 1.86. What is the ratio of the Aid flow (current US$) in Turkmenistan in 2002 to that in 2003?
Offer a terse response. 0.36. What is the ratio of the Aid flow (current US$) of Latin America(developing only) in 2002 to that in 2004?
Make the answer very short. 1.9. What is the ratio of the Aid flow (current US$) in Belarus in 2002 to that in 2004?
Ensure brevity in your answer.  0.45. What is the ratio of the Aid flow (current US$) of Gambia, The in 2002 to that in 2004?
Ensure brevity in your answer.  3.53. What is the ratio of the Aid flow (current US$) of Turkmenistan in 2002 to that in 2004?
Your answer should be compact. 2.18. What is the ratio of the Aid flow (current US$) of Latin America(developing only) in 2002 to that in 2005?
Ensure brevity in your answer.  1.96. What is the ratio of the Aid flow (current US$) of Belarus in 2002 to that in 2005?
Provide a succinct answer. 0.82. What is the ratio of the Aid flow (current US$) in Gambia, The in 2002 to that in 2005?
Your answer should be compact. 1.15. What is the ratio of the Aid flow (current US$) in Turkmenistan in 2002 to that in 2005?
Offer a very short reply. 4.8. What is the ratio of the Aid flow (current US$) of Belarus in 2002 to that in 2007?
Offer a terse response. 0.11. What is the ratio of the Aid flow (current US$) of Gambia, The in 2002 to that in 2007?
Your answer should be compact. 0.34. What is the ratio of the Aid flow (current US$) of Latin America(developing only) in 2003 to that in 2004?
Keep it short and to the point. 0.96. What is the ratio of the Aid flow (current US$) of Belarus in 2003 to that in 2004?
Your answer should be very brief. 0.35. What is the ratio of the Aid flow (current US$) in Gambia, The in 2003 to that in 2004?
Provide a short and direct response. 1.9. What is the ratio of the Aid flow (current US$) in Turkmenistan in 2003 to that in 2004?
Offer a terse response. 6.09. What is the ratio of the Aid flow (current US$) in Latin America(developing only) in 2003 to that in 2005?
Provide a succinct answer. 0.99. What is the ratio of the Aid flow (current US$) in Belarus in 2003 to that in 2005?
Offer a terse response. 0.64. What is the ratio of the Aid flow (current US$) in Gambia, The in 2003 to that in 2005?
Your answer should be compact. 0.62. What is the ratio of the Aid flow (current US$) of Belarus in 2003 to that in 2007?
Your answer should be very brief. 0.09. What is the ratio of the Aid flow (current US$) of Gambia, The in 2003 to that in 2007?
Offer a very short reply. 0.18. What is the ratio of the Aid flow (current US$) in Turkmenistan in 2003 to that in 2007?
Make the answer very short. 2.79. What is the ratio of the Aid flow (current US$) of Latin America(developing only) in 2004 to that in 2005?
Your response must be concise. 1.03. What is the ratio of the Aid flow (current US$) in Belarus in 2004 to that in 2005?
Your answer should be compact. 1.82. What is the ratio of the Aid flow (current US$) in Gambia, The in 2004 to that in 2005?
Make the answer very short. 0.32. What is the ratio of the Aid flow (current US$) of Belarus in 2004 to that in 2007?
Give a very brief answer. 0.24. What is the ratio of the Aid flow (current US$) in Gambia, The in 2004 to that in 2007?
Offer a terse response. 0.1. What is the ratio of the Aid flow (current US$) of Turkmenistan in 2004 to that in 2007?
Your response must be concise. 0.46. What is the ratio of the Aid flow (current US$) of Belarus in 2005 to that in 2007?
Offer a terse response. 0.13. What is the ratio of the Aid flow (current US$) of Gambia, The in 2005 to that in 2007?
Give a very brief answer. 0.3. What is the ratio of the Aid flow (current US$) in Turkmenistan in 2005 to that in 2007?
Your answer should be very brief. 0.21. What is the difference between the highest and the second highest Aid flow (current US$) in Latin America(developing only)?
Offer a terse response. 1.75e+07. What is the difference between the highest and the second highest Aid flow (current US$) in Gambia, The?
Provide a succinct answer. 1.26e+06. What is the difference between the highest and the second highest Aid flow (current US$) in Turkmenistan?
Offer a very short reply. 4.30e+05. What is the difference between the highest and the lowest Aid flow (current US$) of Latin America(developing only)?
Make the answer very short. 3.05e+08. What is the difference between the highest and the lowest Aid flow (current US$) of Belarus?
Your response must be concise. 7.50e+05. What is the difference between the highest and the lowest Aid flow (current US$) of Gambia, The?
Your response must be concise. 4.54e+06. What is the difference between the highest and the lowest Aid flow (current US$) of Turkmenistan?
Offer a terse response. 6.20e+05. 